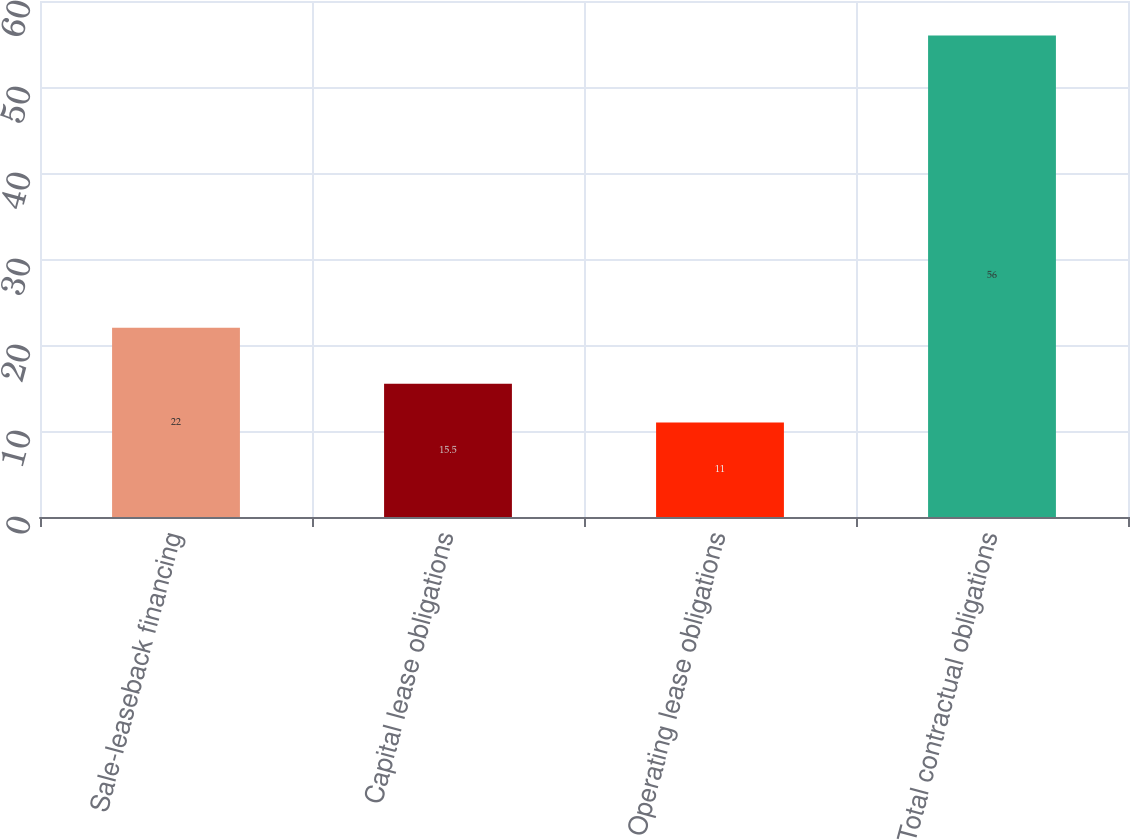<chart> <loc_0><loc_0><loc_500><loc_500><bar_chart><fcel>Sale-leaseback financing<fcel>Capital lease obligations<fcel>Operating lease obligations<fcel>Total contractual obligations<nl><fcel>22<fcel>15.5<fcel>11<fcel>56<nl></chart> 